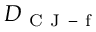<formula> <loc_0><loc_0><loc_500><loc_500>D _ { C J - f }</formula> 